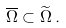<formula> <loc_0><loc_0><loc_500><loc_500>\overline { \Omega } \subset \widetilde { \Omega } \, .</formula> 